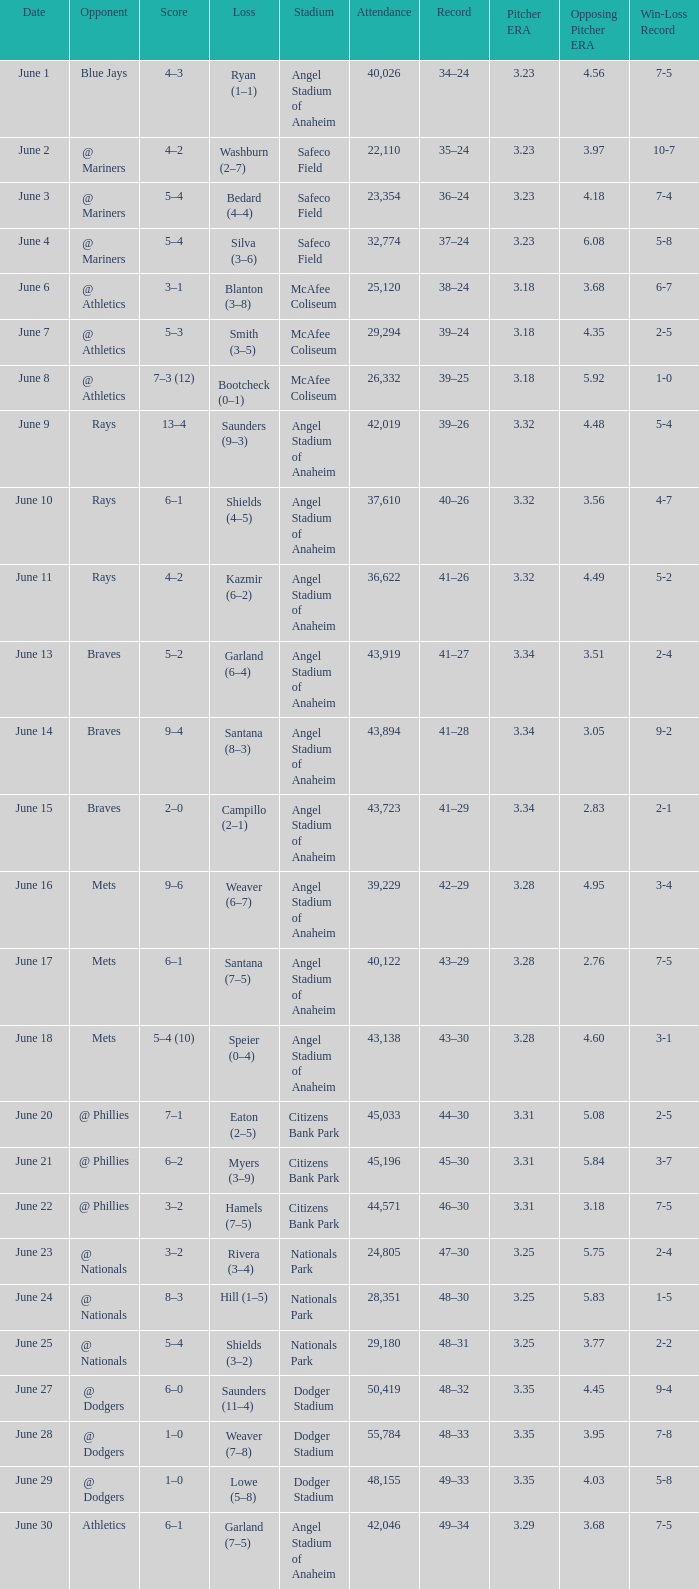What was the score of the game against the Braves with a record of 41–27? 5–2. 